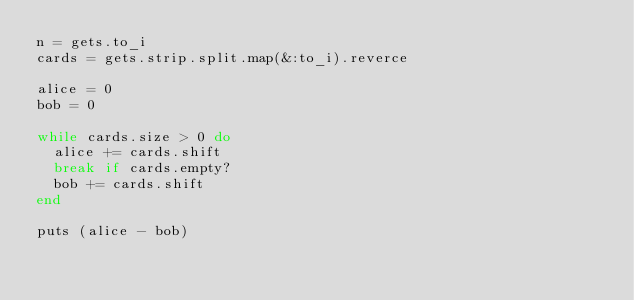<code> <loc_0><loc_0><loc_500><loc_500><_Ruby_>n = gets.to_i
cards = gets.strip.split.map(&:to_i).reverce

alice = 0
bob = 0

while cards.size > 0 do
  alice += cards.shift
  break if cards.empty?
  bob += cards.shift
end

puts (alice - bob) </code> 